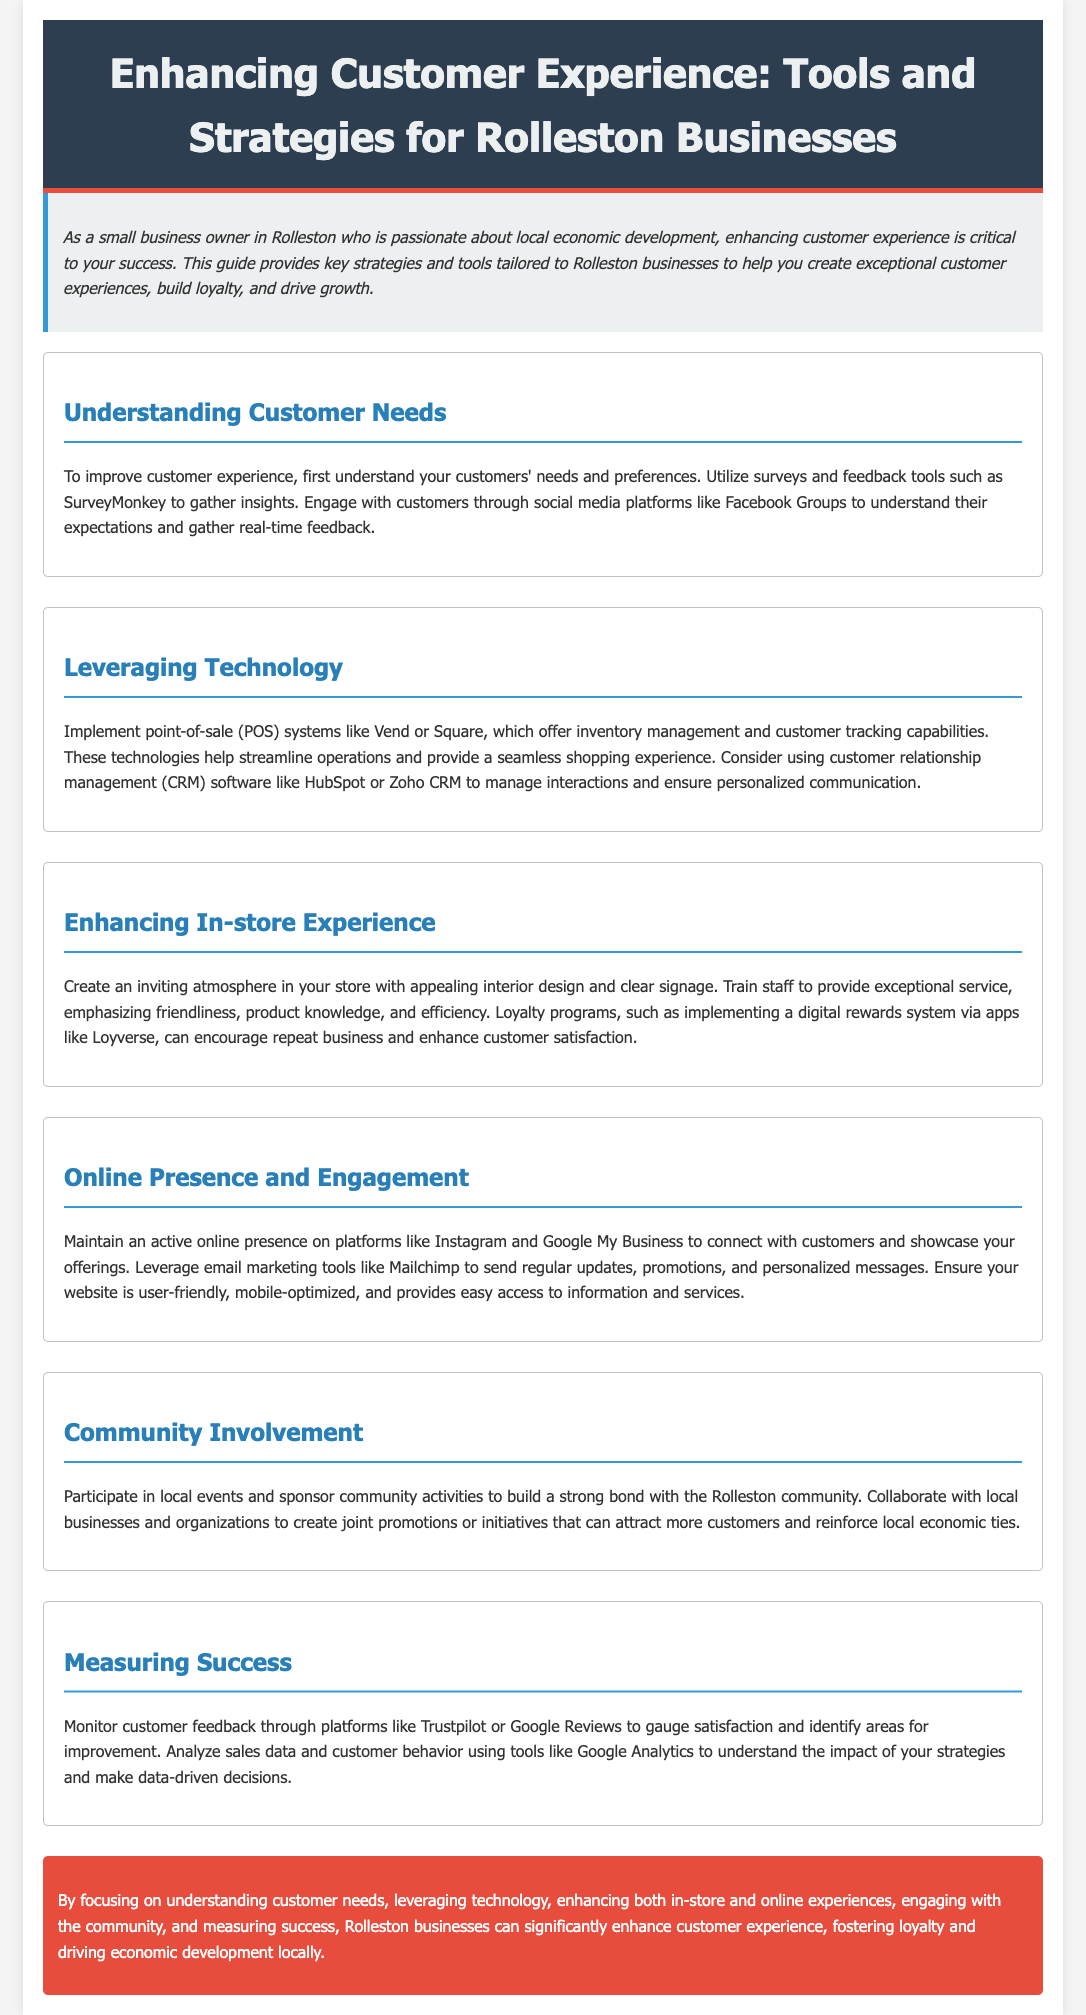What is the title of the document? The title of the document is usually found in the header section, stating the purpose of the guide.
Answer: Enhancing Customer Experience: Tools and Strategies for Rolleston Businesses Which tool is suggested for gathering customer feedback? The document mentions specific tools that can be used to gather feedback from customers.
Answer: SurveyMonkey What software is recommended for managing customer interactions? The guide suggests certain types of software for managing interactions with customers.
Answer: HubSpot or Zoho CRM What is one way to enhance the in-store experience? The document lists various strategies to improve the in-store shopping experience for customers.
Answer: Loyalty programs What online marketing tool is mentioned for sending updates? The document refers to a specific tool for communication via email with customers regarding updates and promotions.
Answer: Mailchimp How can businesses engage with the Rolleston community? The guide provides suggestions on how businesses can build stronger ties within their community to boost local economy.
Answer: Participate in local events What platforms should businesses maintain an active online presence on? Certain online platforms are identified where businesses should be active to connect with customers.
Answer: Instagram and Google My Business What is the primary focus for enhancing customer experience? The introduction highlights the main goal of the strategies presented in the guide.
Answer: Understanding customer needs What tool can be used to analyze sales data? The document mentions specific analytical tools to help understand customer behavior and sales data.
Answer: Google Analytics 